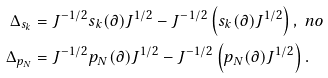<formula> <loc_0><loc_0><loc_500><loc_500>\Delta _ { s _ { k } } & = J ^ { - 1 / 2 } s _ { k } ( \partial ) J ^ { 1 / 2 } - J ^ { - 1 / 2 } \left ( s _ { k } ( \partial ) J ^ { 1 / 2 } \right ) , \ n o \\ \Delta _ { p _ { N } } & = J ^ { - 1 / 2 } p _ { N } ( \partial ) J ^ { 1 / 2 } - J ^ { - 1 / 2 } \left ( p _ { N } ( \partial ) J ^ { 1 / 2 } \right ) .</formula> 